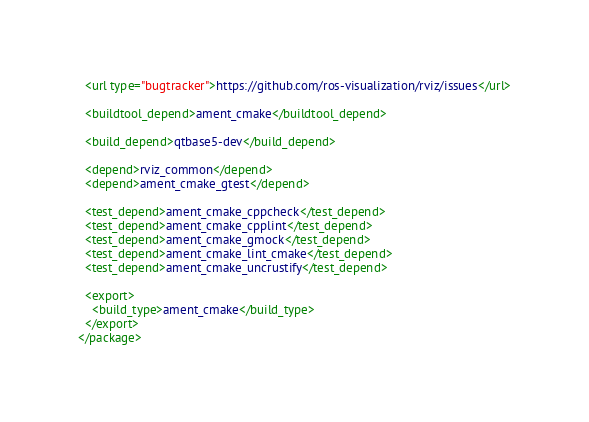<code> <loc_0><loc_0><loc_500><loc_500><_XML_>  <url type="bugtracker">https://github.com/ros-visualization/rviz/issues</url>

  <buildtool_depend>ament_cmake</buildtool_depend>

  <build_depend>qtbase5-dev</build_depend>

  <depend>rviz_common</depend>
  <depend>ament_cmake_gtest</depend>

  <test_depend>ament_cmake_cppcheck</test_depend>
  <test_depend>ament_cmake_cpplint</test_depend>
  <test_depend>ament_cmake_gmock</test_depend>
  <test_depend>ament_cmake_lint_cmake</test_depend>
  <test_depend>ament_cmake_uncrustify</test_depend>

  <export>
    <build_type>ament_cmake</build_type>
  </export>
</package>
</code> 